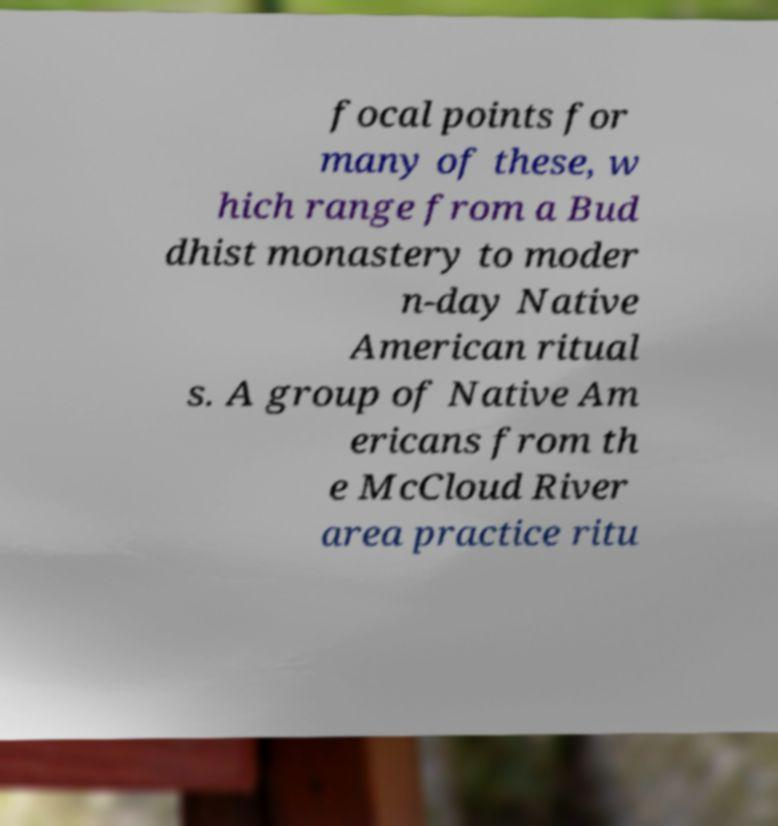What messages or text are displayed in this image? I need them in a readable, typed format. focal points for many of these, w hich range from a Bud dhist monastery to moder n-day Native American ritual s. A group of Native Am ericans from th e McCloud River area practice ritu 